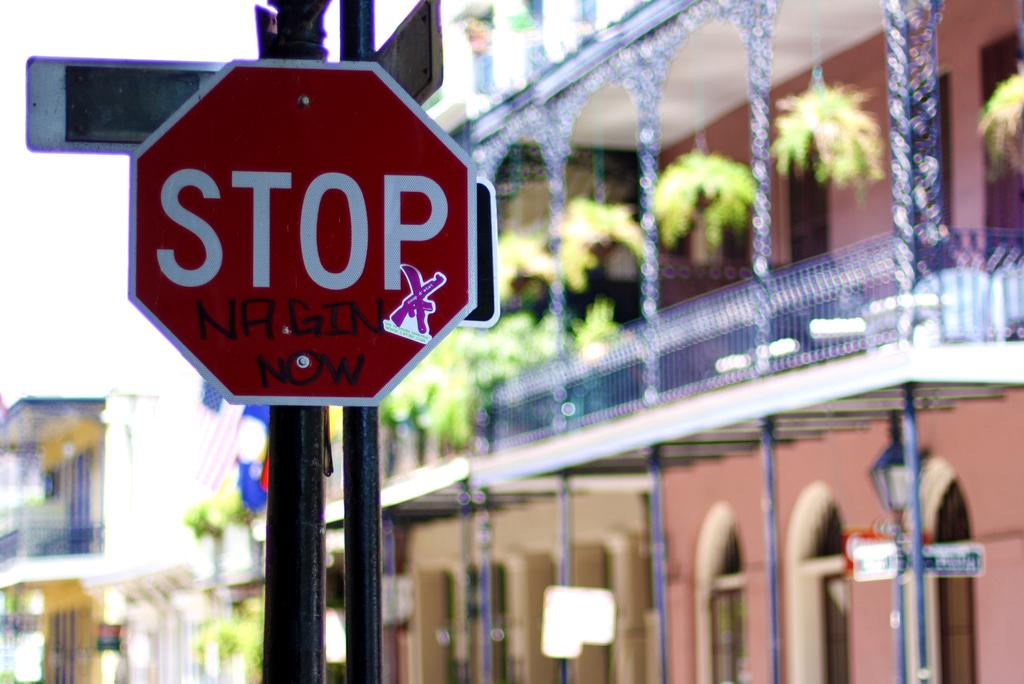What objects are present in the image related to traffic control? There are stop boards in the image. What structure can be seen on the right side of the image? There is a building on the right side of the image. What type of vegetation is near the building? There are potted plants near the building. What is visible at the top of the image? The sky is visible at the top of the image. How would you describe the background of the image? The background of the image is blurred. What time of day is it in the image, considering it's morning? The time of day cannot be determined from the image, and there is no mention of morning in the provided facts. What type of bed is visible in the image? There is no bed present in the image. 